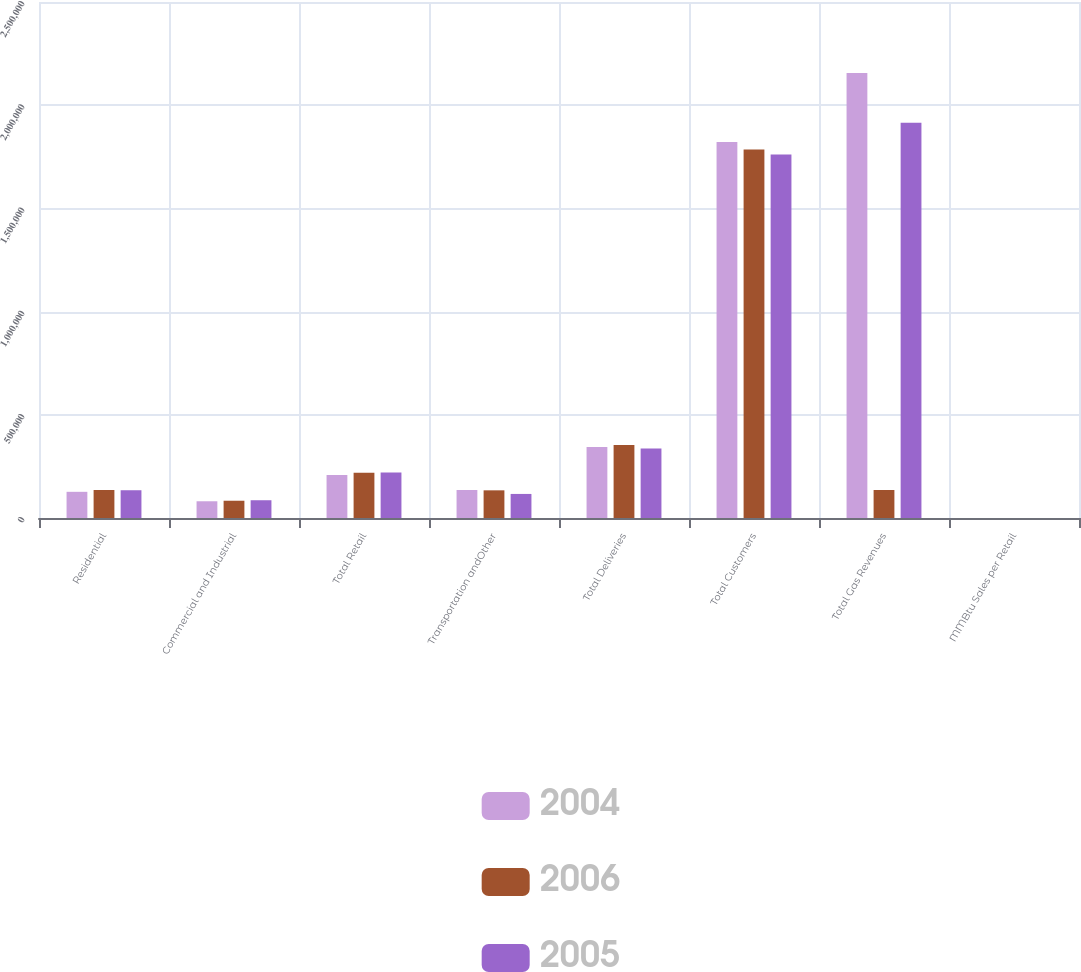Convert chart. <chart><loc_0><loc_0><loc_500><loc_500><stacked_bar_chart><ecel><fcel>Residential<fcel>Commercial and Industrial<fcel>Total Retail<fcel>Transportation andOther<fcel>Total Deliveries<fcel>Total Customers<fcel>Total Gas Revenues<fcel>MMBtu Sales per Retail<nl><fcel>2004<fcel>126846<fcel>81107<fcel>207953<fcel>135708<fcel>343661<fcel>1.82134e+06<fcel>2.156e+06<fcel>114.43<nl><fcel>2006<fcel>135794<fcel>83667<fcel>219461<fcel>134061<fcel>353522<fcel>1.78548e+06<fcel>135794<fcel>123.17<nl><fcel>2005<fcel>134512<fcel>86053<fcel>220565<fcel>116593<fcel>337158<fcel>1.76074e+06<fcel>1.91551e+06<fcel>125.52<nl></chart> 